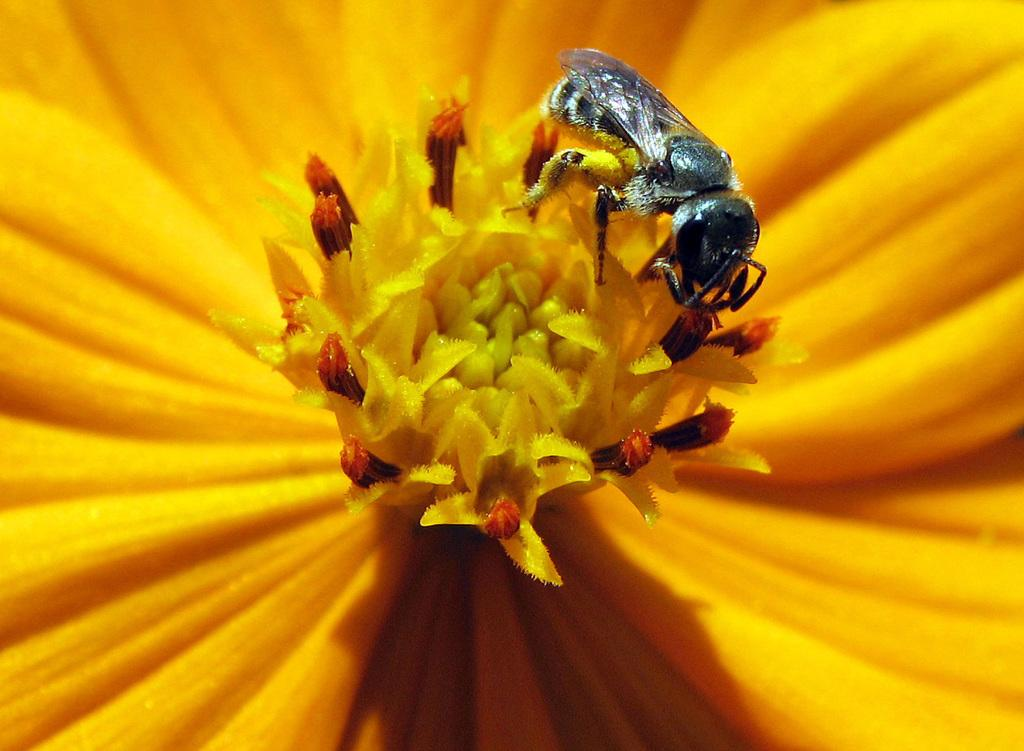What is present on the flower in the image? There is an insect on the flower in the image. Can you describe the insect's location in relation to the flower? The insect is on the flower. What type of stick can be seen holding up the light in the image? There is no stick or light present in the image; it only features an insect on a flower. 